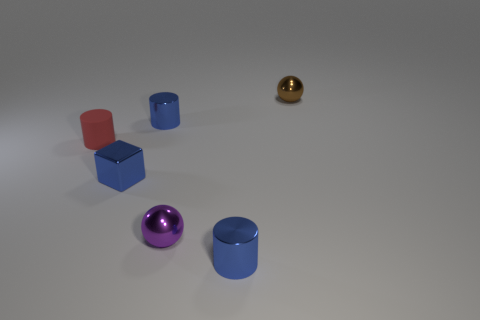Are there any objects made of the same material as the tiny red cylinder?
Your answer should be compact. No. Is the material of the small brown sphere the same as the blue cylinder behind the rubber object?
Your answer should be compact. Yes. There is a matte cylinder that is the same size as the brown thing; what color is it?
Keep it short and to the point. Red. There is a block; is its color the same as the small shiny thing in front of the purple metal object?
Your answer should be very brief. Yes. Is the number of red cylinders left of the small red rubber cylinder less than the number of brown matte things?
Keep it short and to the point. No. How many other things are there of the same size as the red cylinder?
Your answer should be compact. 5. Is the shape of the purple metallic thing in front of the rubber object the same as  the red object?
Make the answer very short. No. Is the number of small red things on the left side of the rubber cylinder greater than the number of blue objects?
Make the answer very short. No. How many things are to the right of the red matte cylinder and on the left side of the tiny brown metallic object?
Your response must be concise. 4. What is the material of the purple object?
Your answer should be compact. Metal. 